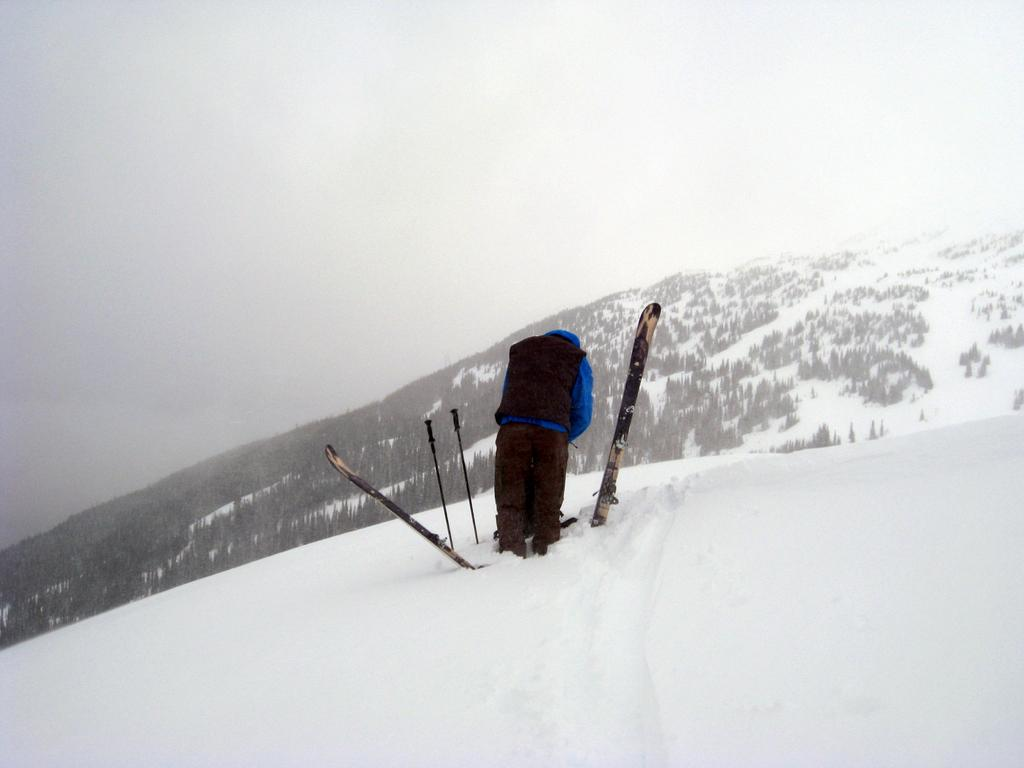Who is in the image? There is a person in the image. What is the person doing in the image? The person is using skiboards and ski poles in the image. What type of terrain is visible in the image? The scene takes place on snow, and there is a mountain in the middle of the image. What is visible at the top of the image? The sky is visible at the top of the image. What type of wilderness can be seen in the image? There is no wilderness present in the image; it features a person skiing on snow with a mountain in the background. Can you tell me how many yaks are visible in the image? There are no yaks present in the image. 